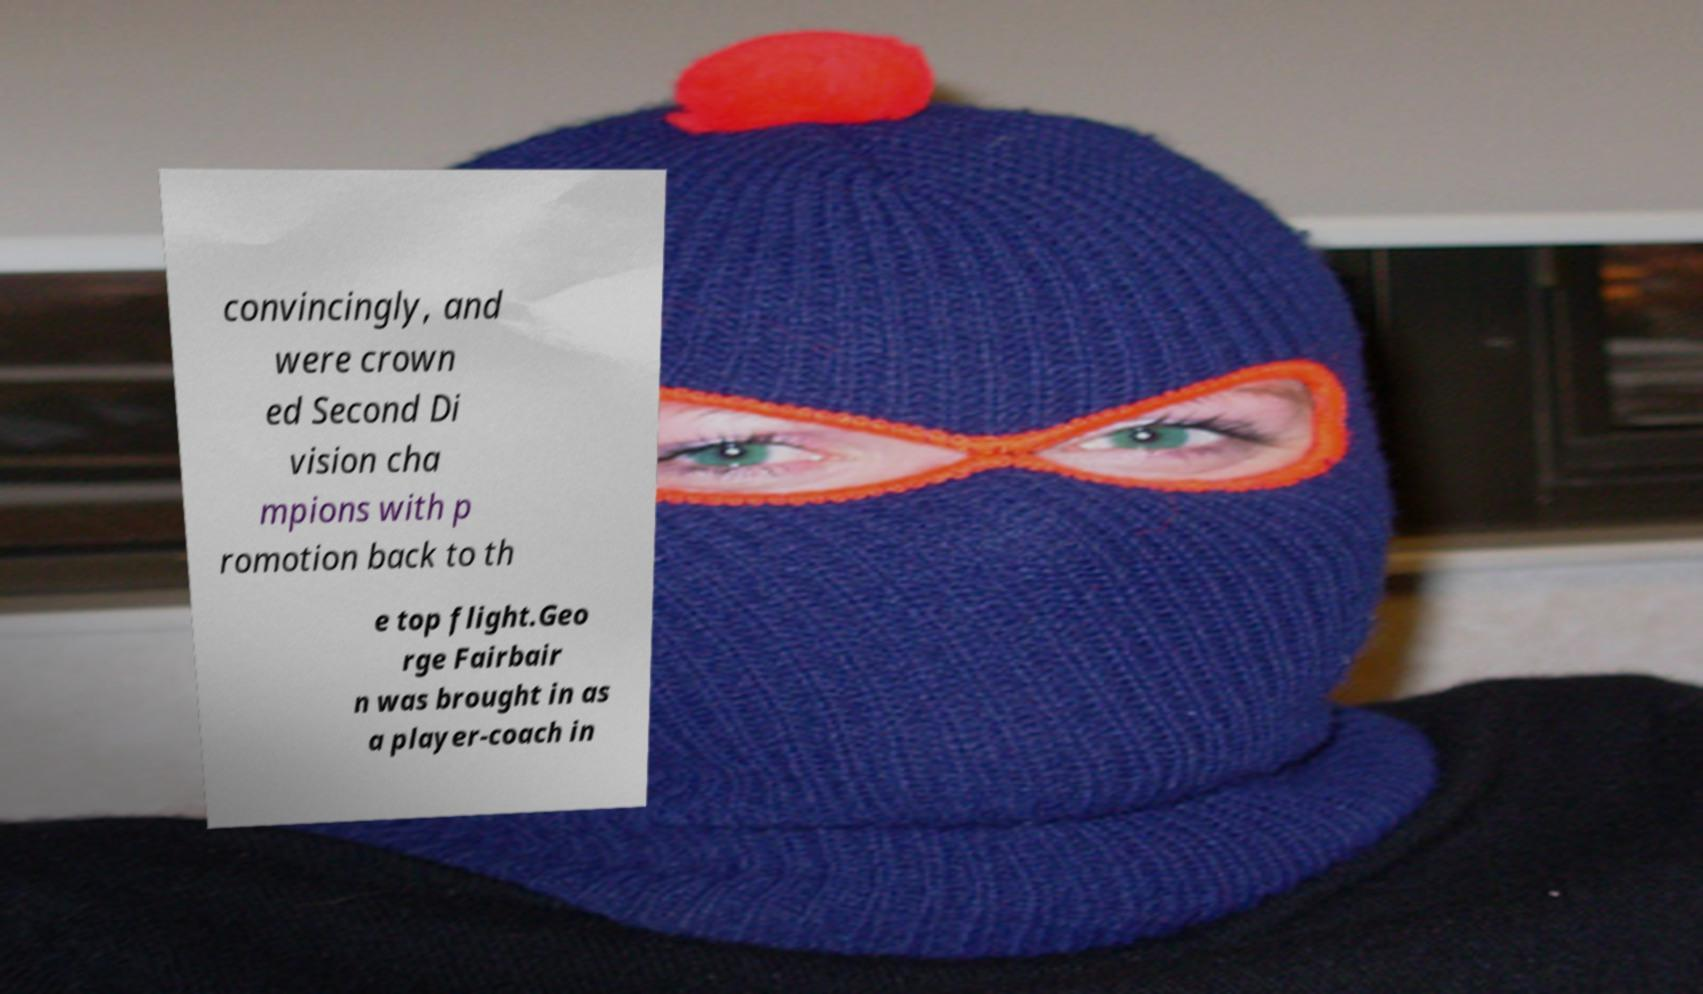Can you read and provide the text displayed in the image?This photo seems to have some interesting text. Can you extract and type it out for me? convincingly, and were crown ed Second Di vision cha mpions with p romotion back to th e top flight.Geo rge Fairbair n was brought in as a player-coach in 